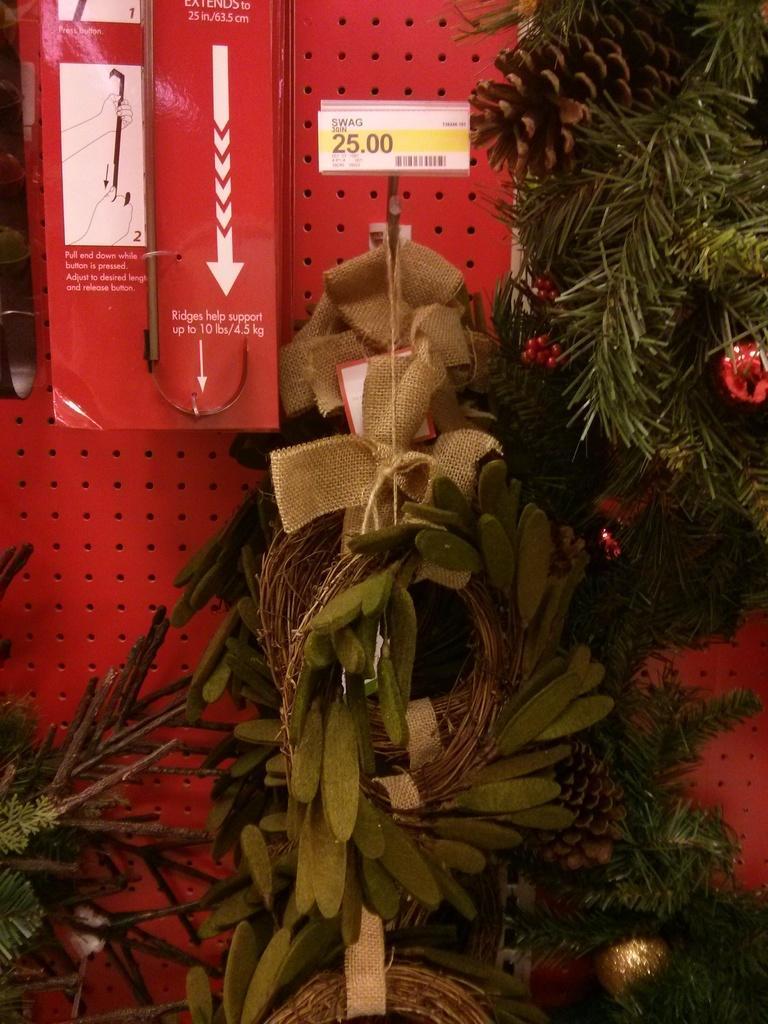Describe this image in one or two sentences. In the image we can see some plants. Behind the plants there is wall, on the wall there is a box. 